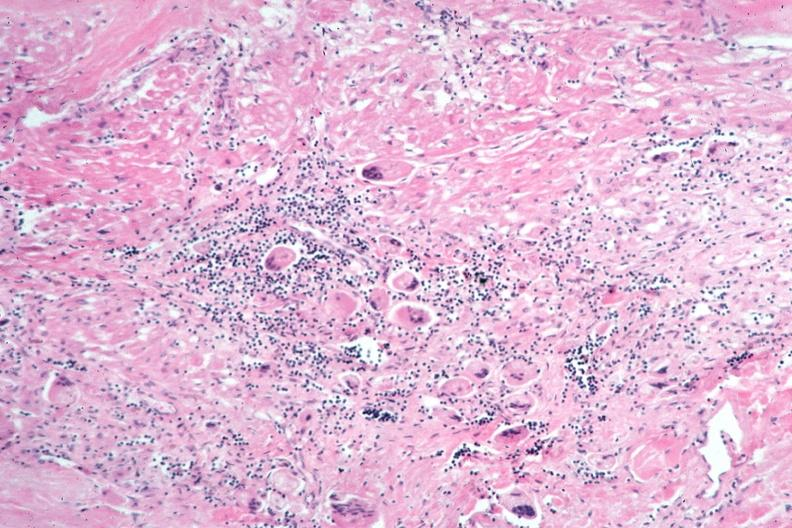what is present?
Answer the question using a single word or phrase. Respiratory 